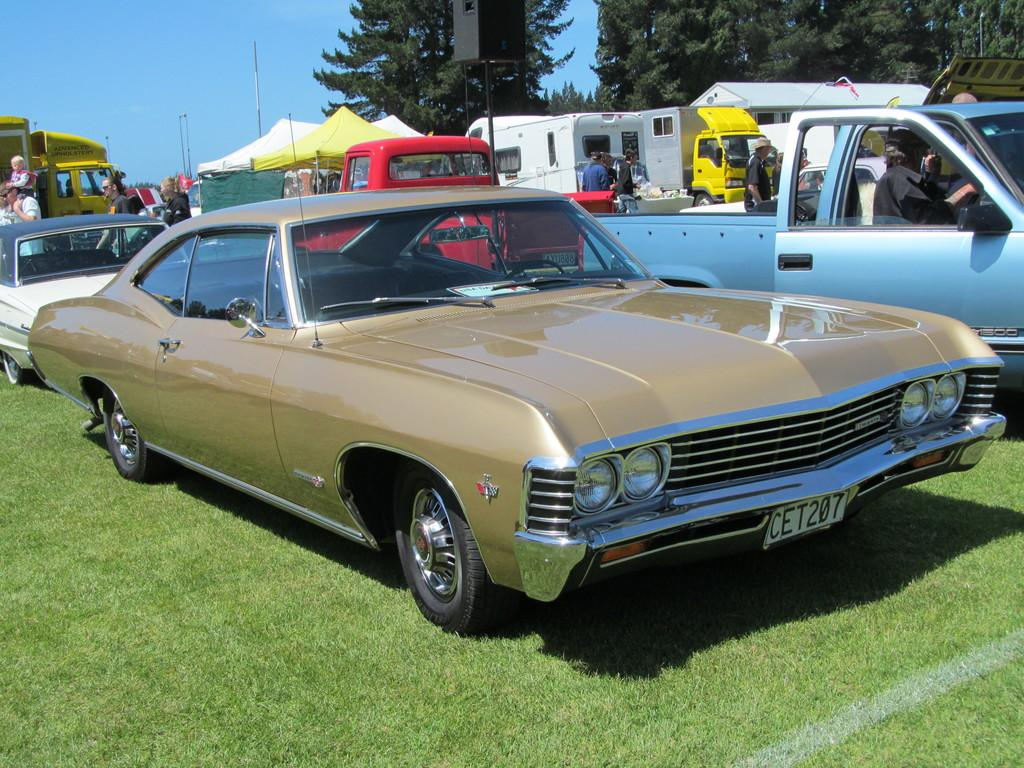What type of vehicles can be seen in the image? There are cars in the image. Who or what else is present in the image besides the cars? There are persons and trees in the image. What is the ground covered with in the image? There is grass on the ground in the image. What can be seen in the background of the image? There are poles in the background of the image. What type of bone can be seen in the image? There is no bone present in the image. What shape is the rest area in the image? There is no rest area mentioned in the image; it only contains cars, persons, trees, grass, and poles. 